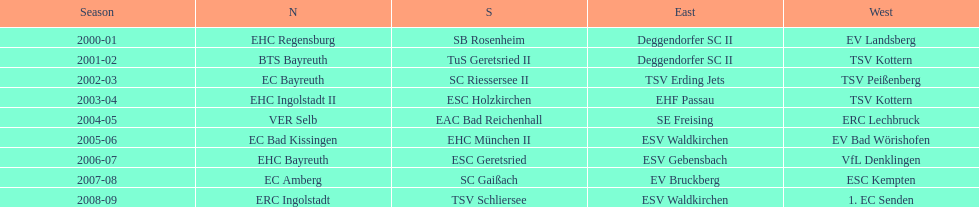Who won the south after esc geretsried did during the 2006-07 season? SC Gaißach. 